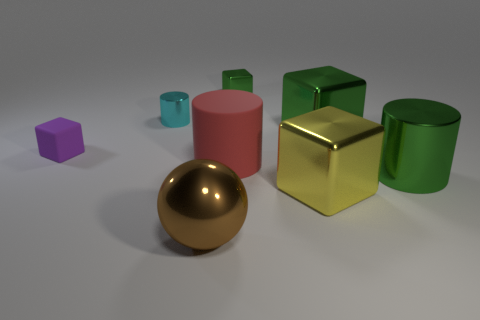Do the large cube that is behind the purple matte object and the metal block to the left of the big yellow block have the same color?
Keep it short and to the point. Yes. The cylinder that is the same color as the tiny metallic cube is what size?
Make the answer very short. Large. There is a small object that is behind the tiny cylinder behind the big green metal object behind the big green shiny cylinder; what is its color?
Your answer should be compact. Green. What color is the shiny cylinder that is the same size as the purple matte cube?
Make the answer very short. Cyan. What shape is the big green thing to the left of the large shiny cylinder in front of the tiny cube that is to the left of the large brown thing?
Ensure brevity in your answer.  Cube. How many things are metal objects or large brown balls in front of the matte cube?
Ensure brevity in your answer.  6. Is the size of the shiny cylinder to the right of the red object the same as the tiny green block?
Your answer should be very brief. No. There is a big block behind the tiny purple matte thing; what is it made of?
Keep it short and to the point. Metal. Are there an equal number of purple rubber blocks that are in front of the large metallic sphere and metal spheres that are to the right of the tiny green shiny thing?
Your answer should be very brief. Yes. The tiny object that is the same shape as the large rubber object is what color?
Make the answer very short. Cyan. 